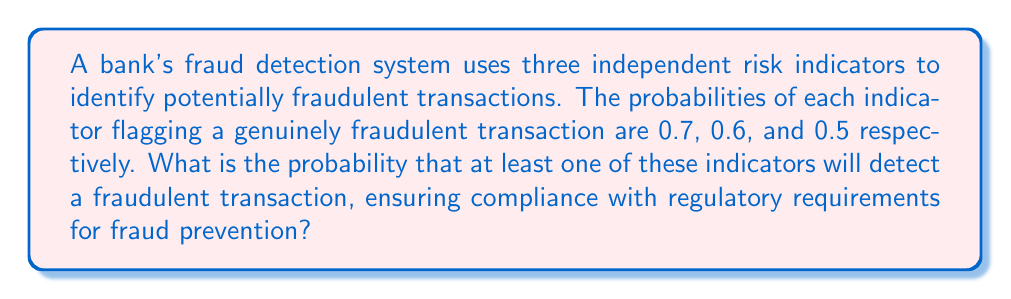Can you answer this question? To solve this problem, we'll use the complementary probability approach:

1) First, let's define our events:
   A: First indicator detects fraud
   B: Second indicator detects fraud
   C: Third indicator detects fraud

2) We're looking for P(at least one indicator detects fraud) = 1 - P(no indicator detects fraud)

3) Given:
   P(A) = 0.7
   P(B) = 0.6
   P(C) = 0.5

4) The probability that an indicator doesn't detect fraud is the complement of it detecting fraud:
   P(not A) = 1 - P(A) = 1 - 0.7 = 0.3
   P(not B) = 1 - P(B) = 1 - 0.6 = 0.4
   P(not C) = 1 - P(C) = 1 - 0.5 = 0.5

5) The probability that none of the indicators detect fraud is the product of the individual probabilities of not detecting fraud (since the indicators are independent):

   P(no indicator detects fraud) = P(not A) × P(not B) × P(not C)
                                  = 0.3 × 0.4 × 0.5
                                  = 0.06

6) Therefore, the probability that at least one indicator detects fraud is:

   P(at least one indicator detects fraud) = 1 - P(no indicator detects fraud)
                                           = 1 - 0.06
                                           = 0.94

Thus, there is a 94% chance that at least one of the indicators will detect a fraudulent transaction.
Answer: 0.94 